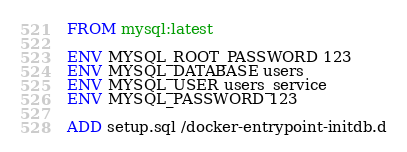Convert code to text. <code><loc_0><loc_0><loc_500><loc_500><_Dockerfile_>FROM mysql:latest

ENV MYSQL_ROOT_PASSWORD 123
ENV MYSQL_DATABASE users
ENV MYSQL_USER users_service
ENV MYSQL_PASSWORD 123

ADD setup.sql /docker-entrypoint-initdb.d
</code> 